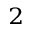<formula> <loc_0><loc_0><loc_500><loc_500>_ { 2 }</formula> 